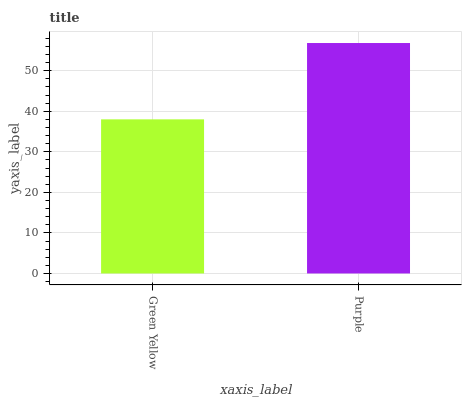Is Green Yellow the minimum?
Answer yes or no. Yes. Is Purple the maximum?
Answer yes or no. Yes. Is Purple the minimum?
Answer yes or no. No. Is Purple greater than Green Yellow?
Answer yes or no. Yes. Is Green Yellow less than Purple?
Answer yes or no. Yes. Is Green Yellow greater than Purple?
Answer yes or no. No. Is Purple less than Green Yellow?
Answer yes or no. No. Is Purple the high median?
Answer yes or no. Yes. Is Green Yellow the low median?
Answer yes or no. Yes. Is Green Yellow the high median?
Answer yes or no. No. Is Purple the low median?
Answer yes or no. No. 